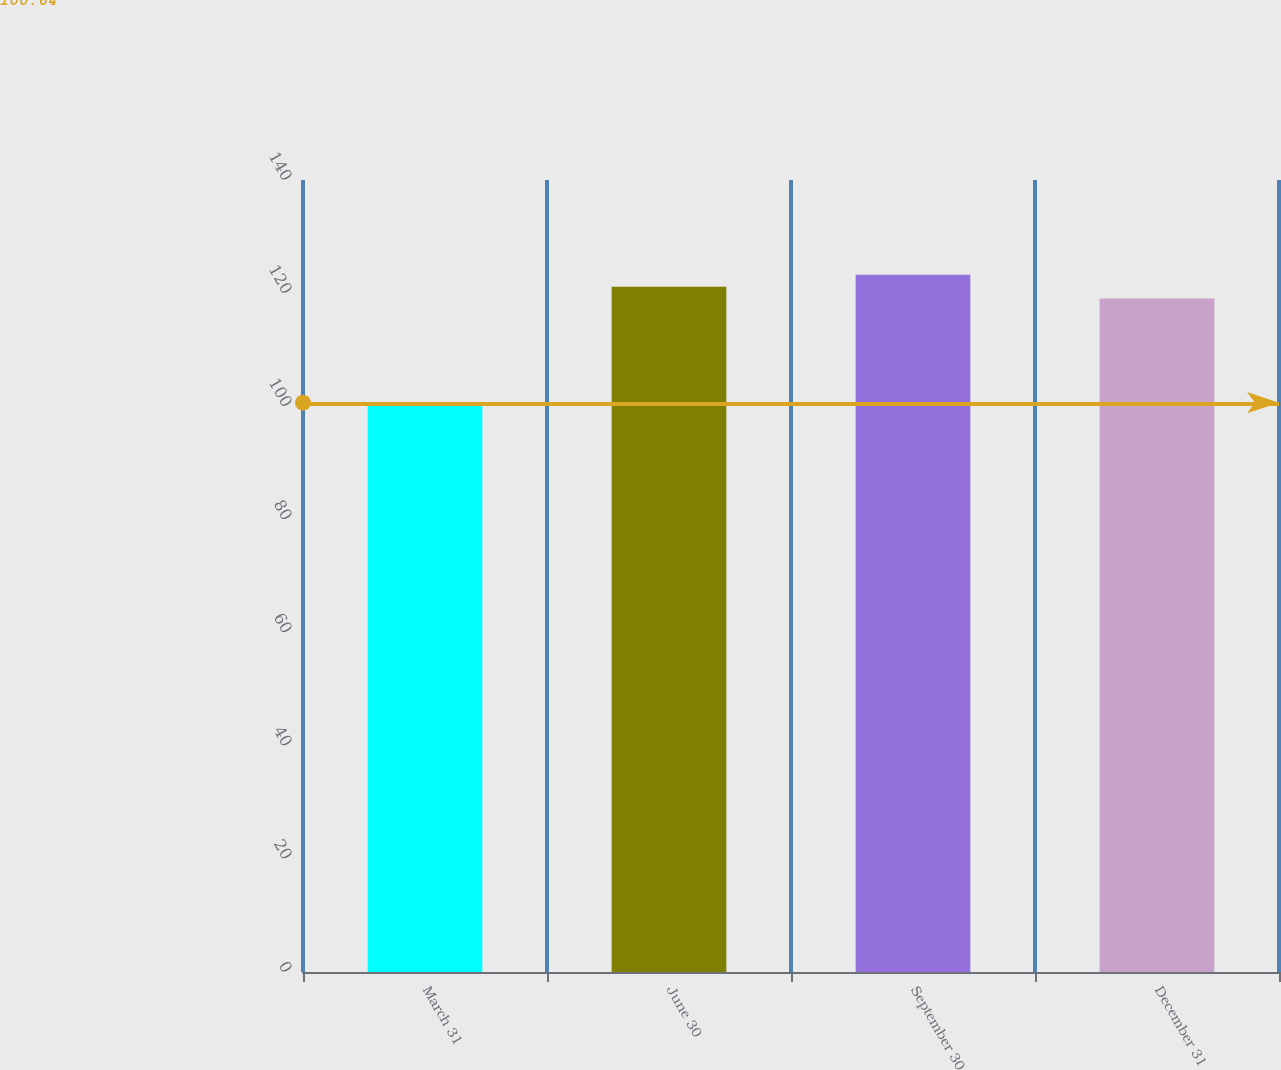Convert chart. <chart><loc_0><loc_0><loc_500><loc_500><bar_chart><fcel>March 31<fcel>June 30<fcel>September 30<fcel>December 31<nl><fcel>100.48<fcel>121.14<fcel>123.24<fcel>119.04<nl></chart> 